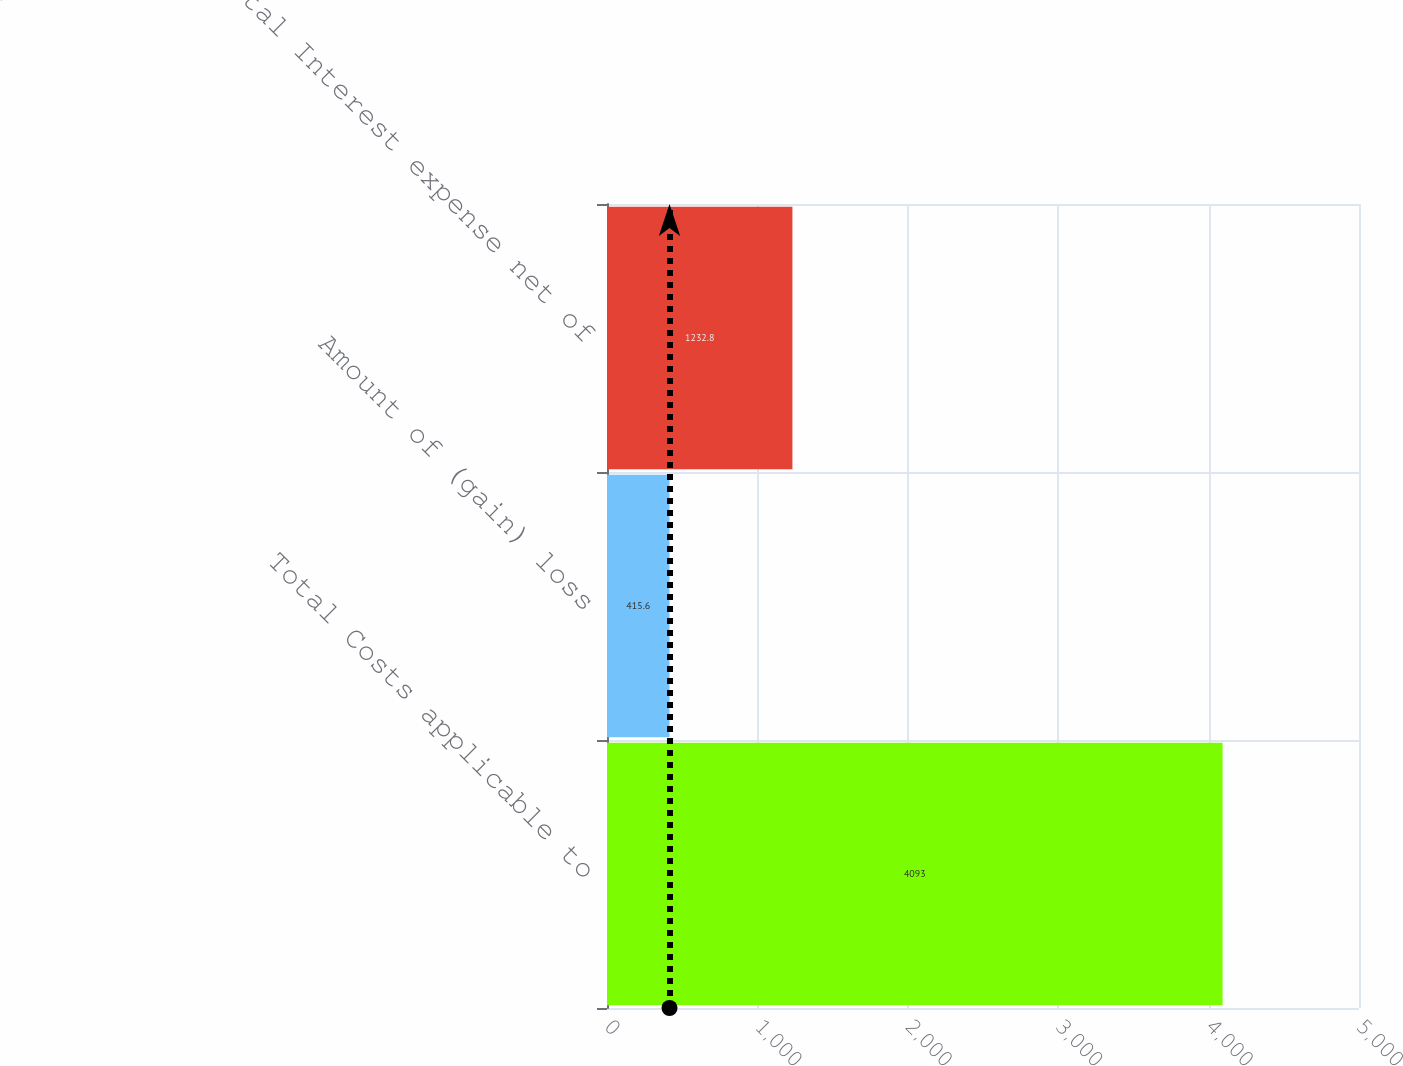Convert chart. <chart><loc_0><loc_0><loc_500><loc_500><bar_chart><fcel>Total Costs applicable to<fcel>Amount of (gain) loss<fcel>Total Interest expense net of<nl><fcel>4093<fcel>415.6<fcel>1232.8<nl></chart> 